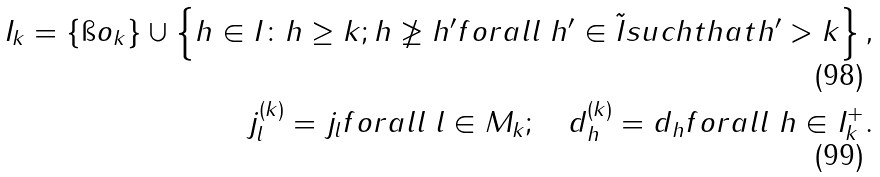Convert formula to latex. <formula><loc_0><loc_0><loc_500><loc_500>I _ { k } = \{ \i o _ { k } \} \cup \left \{ h \in I \colon h \geq k ; h \not \geq h ^ { \prime } f o r a l l \ h ^ { \prime } \in \tilde { I } s u c h t h a t h ^ { \prime } > k \right \} , \\ j ^ { ( k ) } _ { l } = j _ { l } f o r a l l \ l \in M _ { k } ; \quad d ^ { ( k ) } _ { h } = d _ { h } f o r a l l \ h \in I _ { k } ^ { + } .</formula> 